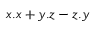<formula> <loc_0><loc_0><loc_500><loc_500>x . x + y . z - z . y</formula> 